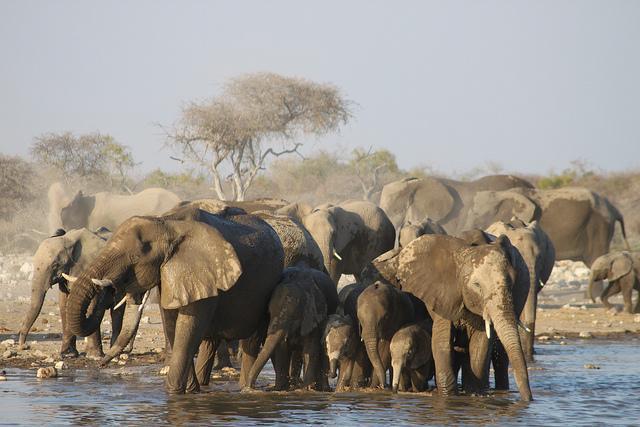How many elephants can you see?
Give a very brief answer. 13. How many trees are on between the yellow car and the building?
Give a very brief answer. 0. 